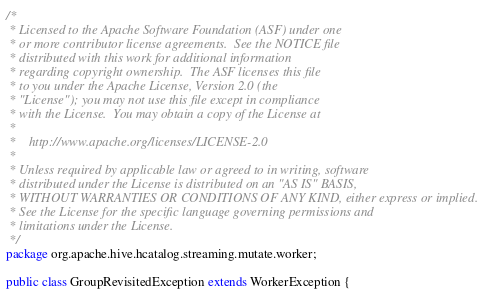Convert code to text. <code><loc_0><loc_0><loc_500><loc_500><_Java_>/*
 * Licensed to the Apache Software Foundation (ASF) under one
 * or more contributor license agreements.  See the NOTICE file
 * distributed with this work for additional information
 * regarding copyright ownership.  The ASF licenses this file
 * to you under the Apache License, Version 2.0 (the
 * "License"); you may not use this file except in compliance
 * with the License.  You may obtain a copy of the License at
 *
 *    http://www.apache.org/licenses/LICENSE-2.0
 *
 * Unless required by applicable law or agreed to in writing, software
 * distributed under the License is distributed on an "AS IS" BASIS,
 * WITHOUT WARRANTIES OR CONDITIONS OF ANY KIND, either express or implied.
 * See the License for the specific language governing permissions and
 * limitations under the License.
 */
package org.apache.hive.hcatalog.streaming.mutate.worker;

public class GroupRevisitedException extends WorkerException {
</code> 